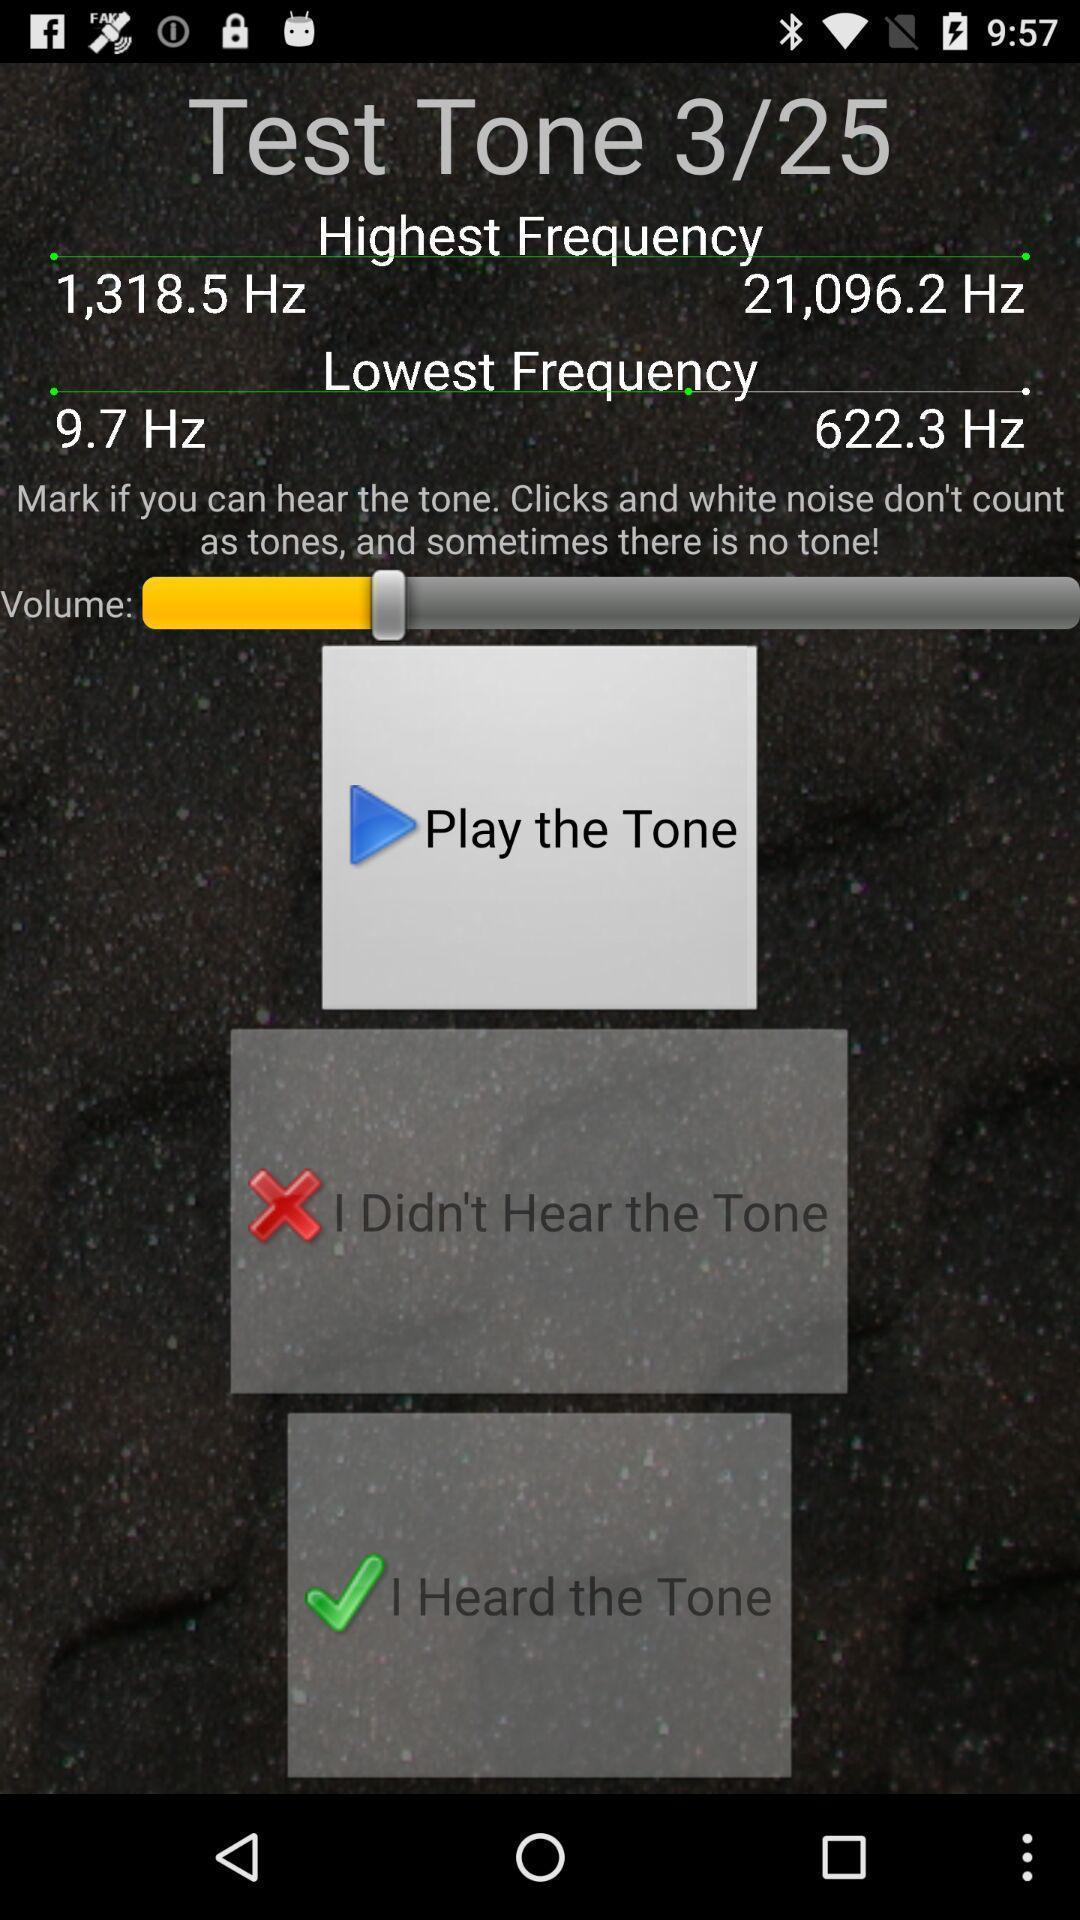Explain what's happening in this screen capture. Screen shows the fun game of test tone. 